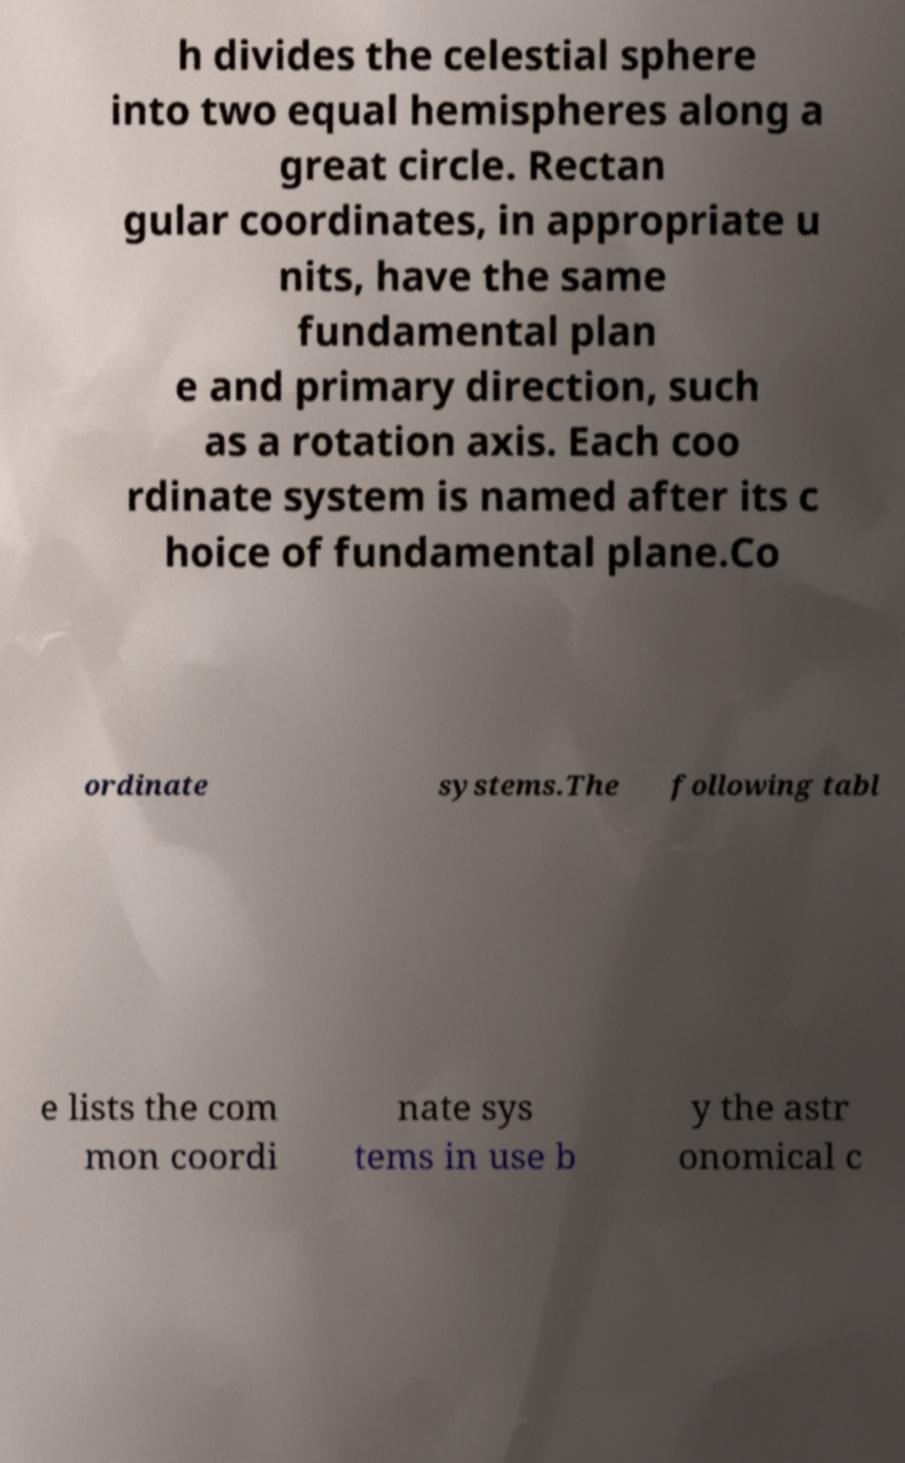Could you extract and type out the text from this image? h divides the celestial sphere into two equal hemispheres along a great circle. Rectan gular coordinates, in appropriate u nits, have the same fundamental plan e and primary direction, such as a rotation axis. Each coo rdinate system is named after its c hoice of fundamental plane.Co ordinate systems.The following tabl e lists the com mon coordi nate sys tems in use b y the astr onomical c 